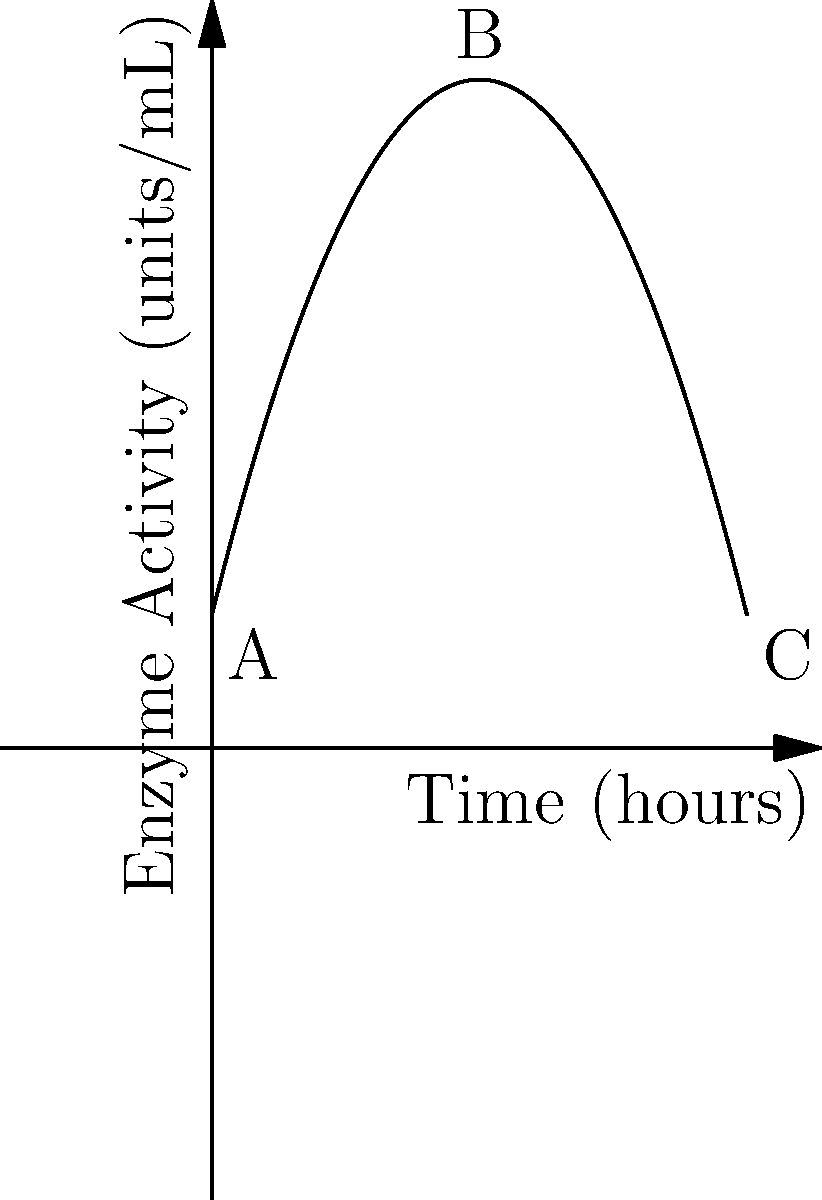A quadratic polynomial graph represents the enzyme activity in a patient's blood sample over time. The enzyme activity (in units/mL) is given by the function $f(t) = -0.5t^2 + 4t + 2$, where $t$ is time in hours. At what time does the enzyme activity reach its maximum, and what is the rate of change of enzyme activity at 6 hours after the initial measurement? To solve this problem, we'll follow these steps:

1. Find the maximum enzyme activity:
   The maximum of a quadratic function occurs at the vertex of the parabola.
   For a quadratic function in the form $f(t) = at^2 + bt + c$, the t-coordinate of the vertex is given by $t = -\frac{b}{2a}$.
   
   Here, $a = -0.5$, $b = 4$, so:
   $t = -\frac{4}{2(-0.5)} = -\frac{4}{-1} = 4$ hours

2. Calculate the rate of change at 6 hours:
   The rate of change is given by the derivative of the function.
   $f'(t) = -t + 4$
   
   At $t = 6$ hours:
   $f'(6) = -6 + 4 = -2$ units/mL per hour

Therefore, the enzyme activity reaches its maximum at 4 hours, and the rate of change at 6 hours is -2 units/mL per hour.
Answer: Maximum at 4 hours; Rate of change at 6 hours: -2 units/mL/hour 